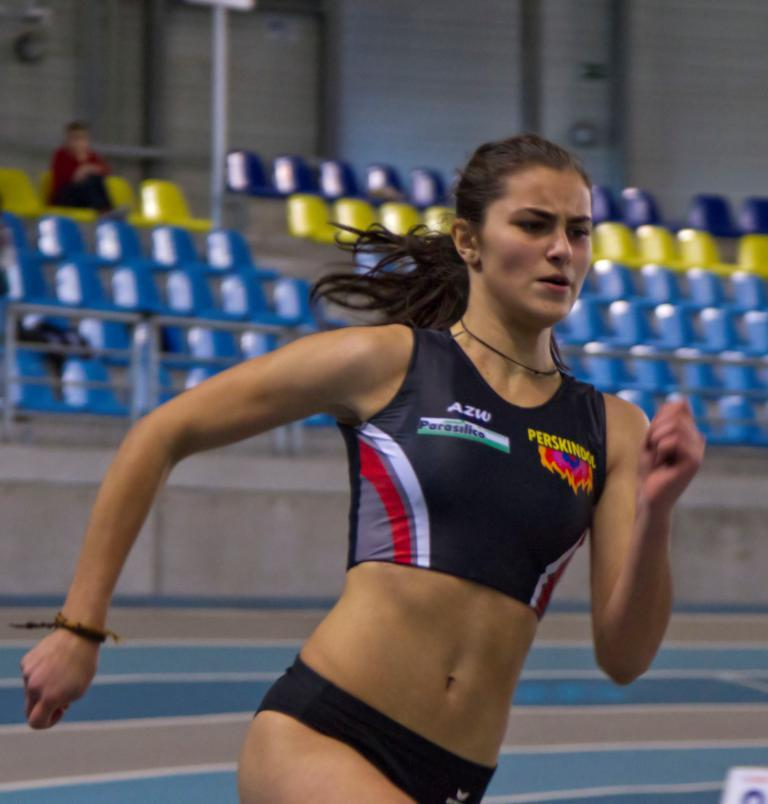Provide a one-sentence caption for the provided image. A woman running wearing a shirt that reads Perskindol. 